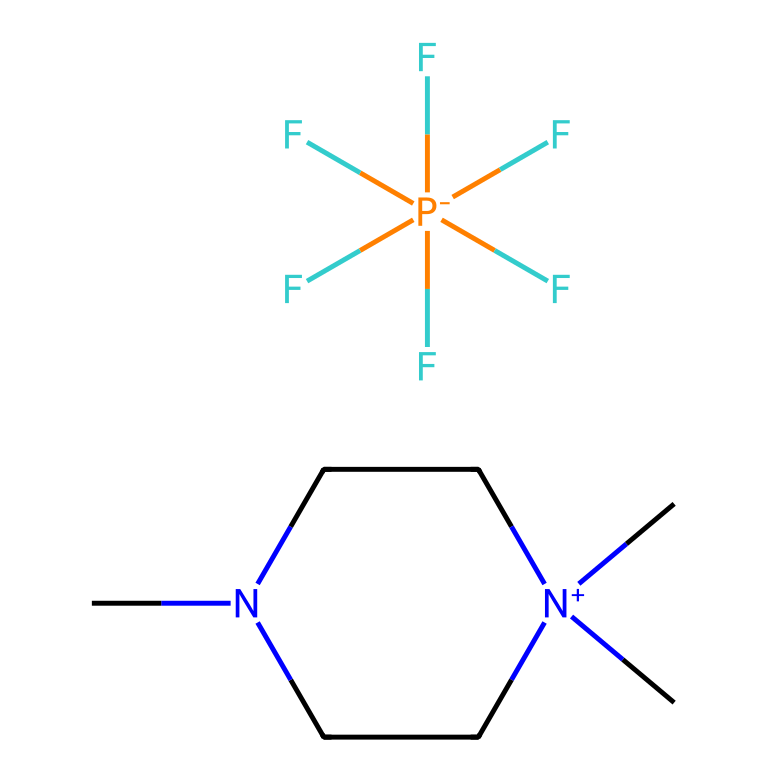What is the cation present in this ionic liquid? The cation is represented by the part of the SMILES that contains the positively charged nitrogen atom and carbon structure. In this case, it's the structure including C1CN(CC[N+]1(C)C).
Answer: C1CN(CC[N+]1(C)C) How many fluorine atoms are in the anion of this ionic liquid? The anion of this ionic liquid is indicated by the section that contains the phosphorus atom and surrounding fluorine atoms. Counting the F symbols shows there are five fluorine atoms.
Answer: 5 Identify the anion in this ionic liquid. The anion is the part of the SMILES that concludes with the phosphorus and fluorine atoms, represented as F[P-](F)(F)(F)(F)F. This indicates it is a perfluorinated phosphonium ion.
Answer: F[P-](F)(F)(F)(F)F What type of bonding is primarily present in the ionic liquid? The structure is primarily held together by ionic bonds due to the presence of a cation and an anion interacting via electrostatic attraction, characteristic of ionic liquids.
Answer: Ionic bonds What does the symbol [N+] indicate in the cation? The [N+] symbol indicates that the nitrogen atom carries a positive charge, which creates a cationic species within the ionic liquid, contributing to its ionic nature.
Answer: Positive charge What makes ionic liquids like this one suitable for high-performance batteries? The presence of a low viscosity and high ionic conductivity, which is a result of the ionic nature and unique composition, allows for efficient charge transfer in high-performance batteries.
Answer: Low viscosity and high ionic conductivity 